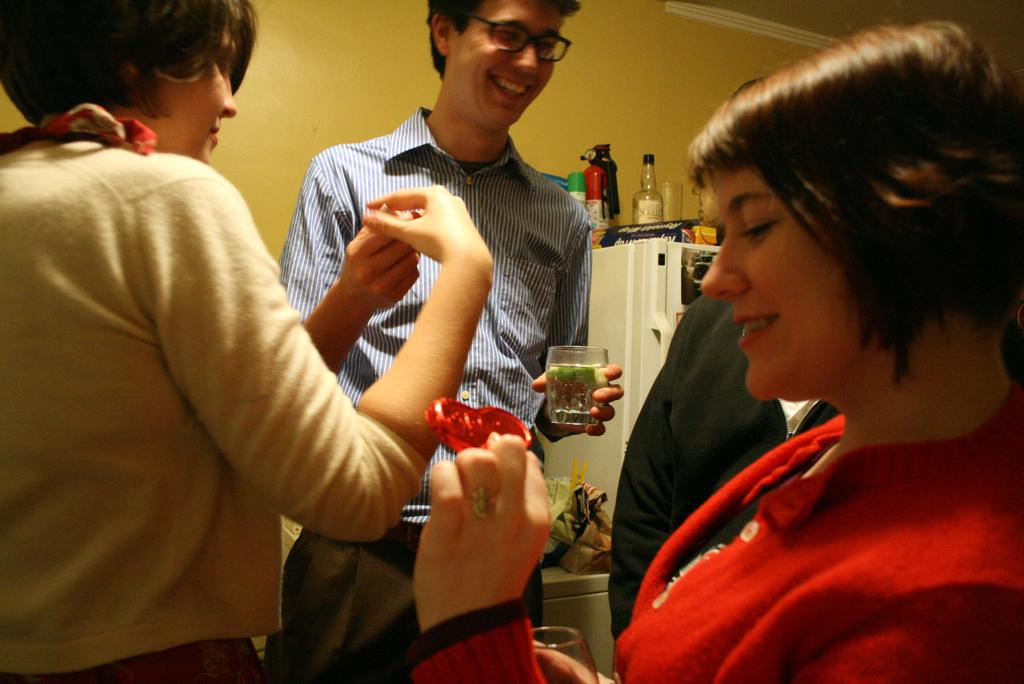What are the persons in the image doing? The persons in the image are standing and holding glasses and toffee. What objects are the persons holding in the image? The persons are holding glasses and toffee. What can be seen in the background of the image? There is a fridge in the background of the image, and above the fridge, there are bottles. Can you tell me how many rifles are visible in the image? There are no rifles present in the image. What type of cart is being used by the persons in the image? There is no cart present in the image; the persons are standing and holding glasses and toffee. 